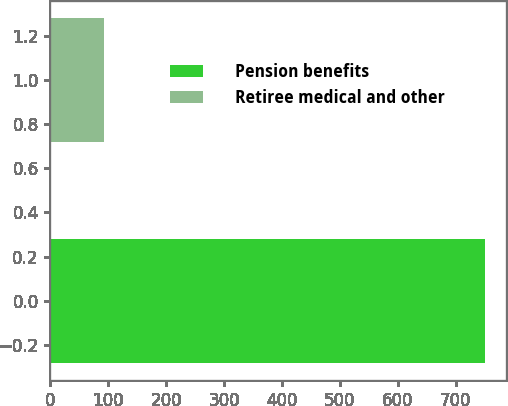Convert chart to OTSL. <chart><loc_0><loc_0><loc_500><loc_500><bar_chart><fcel>Pension benefits<fcel>Retiree medical and other<nl><fcel>750<fcel>92<nl></chart> 